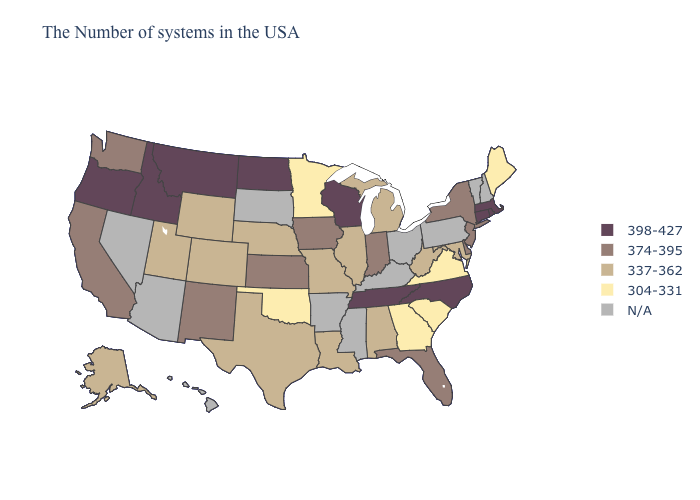Name the states that have a value in the range 374-395?
Quick response, please. New York, New Jersey, Delaware, Florida, Indiana, Iowa, Kansas, New Mexico, California, Washington. What is the lowest value in the USA?
Concise answer only. 304-331. What is the highest value in the USA?
Concise answer only. 398-427. Name the states that have a value in the range 374-395?
Answer briefly. New York, New Jersey, Delaware, Florida, Indiana, Iowa, Kansas, New Mexico, California, Washington. Does Tennessee have the highest value in the South?
Write a very short answer. Yes. What is the value of Oregon?
Concise answer only. 398-427. Among the states that border Massachusetts , does Connecticut have the highest value?
Answer briefly. Yes. Does Colorado have the highest value in the West?
Give a very brief answer. No. What is the lowest value in the Northeast?
Be succinct. 304-331. What is the lowest value in states that border Arizona?
Concise answer only. 337-362. Among the states that border Kansas , does Colorado have the highest value?
Keep it brief. Yes. Name the states that have a value in the range 337-362?
Answer briefly. Maryland, West Virginia, Michigan, Alabama, Illinois, Louisiana, Missouri, Nebraska, Texas, Wyoming, Colorado, Utah, Alaska. 